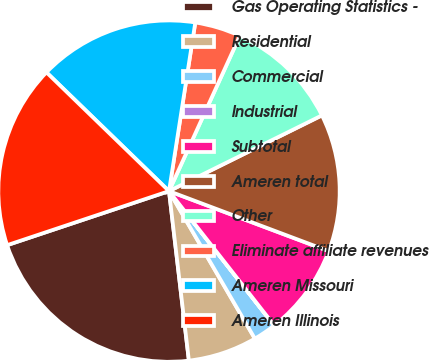Convert chart to OTSL. <chart><loc_0><loc_0><loc_500><loc_500><pie_chart><fcel>Gas Operating Statistics -<fcel>Residential<fcel>Commercial<fcel>Industrial<fcel>Subtotal<fcel>Ameren total<fcel>Other<fcel>Eliminate affiliate revenues<fcel>Ameren Missouri<fcel>Ameren Illinois<nl><fcel>21.73%<fcel>6.53%<fcel>2.18%<fcel>0.01%<fcel>8.7%<fcel>13.04%<fcel>10.87%<fcel>4.35%<fcel>15.21%<fcel>17.38%<nl></chart> 